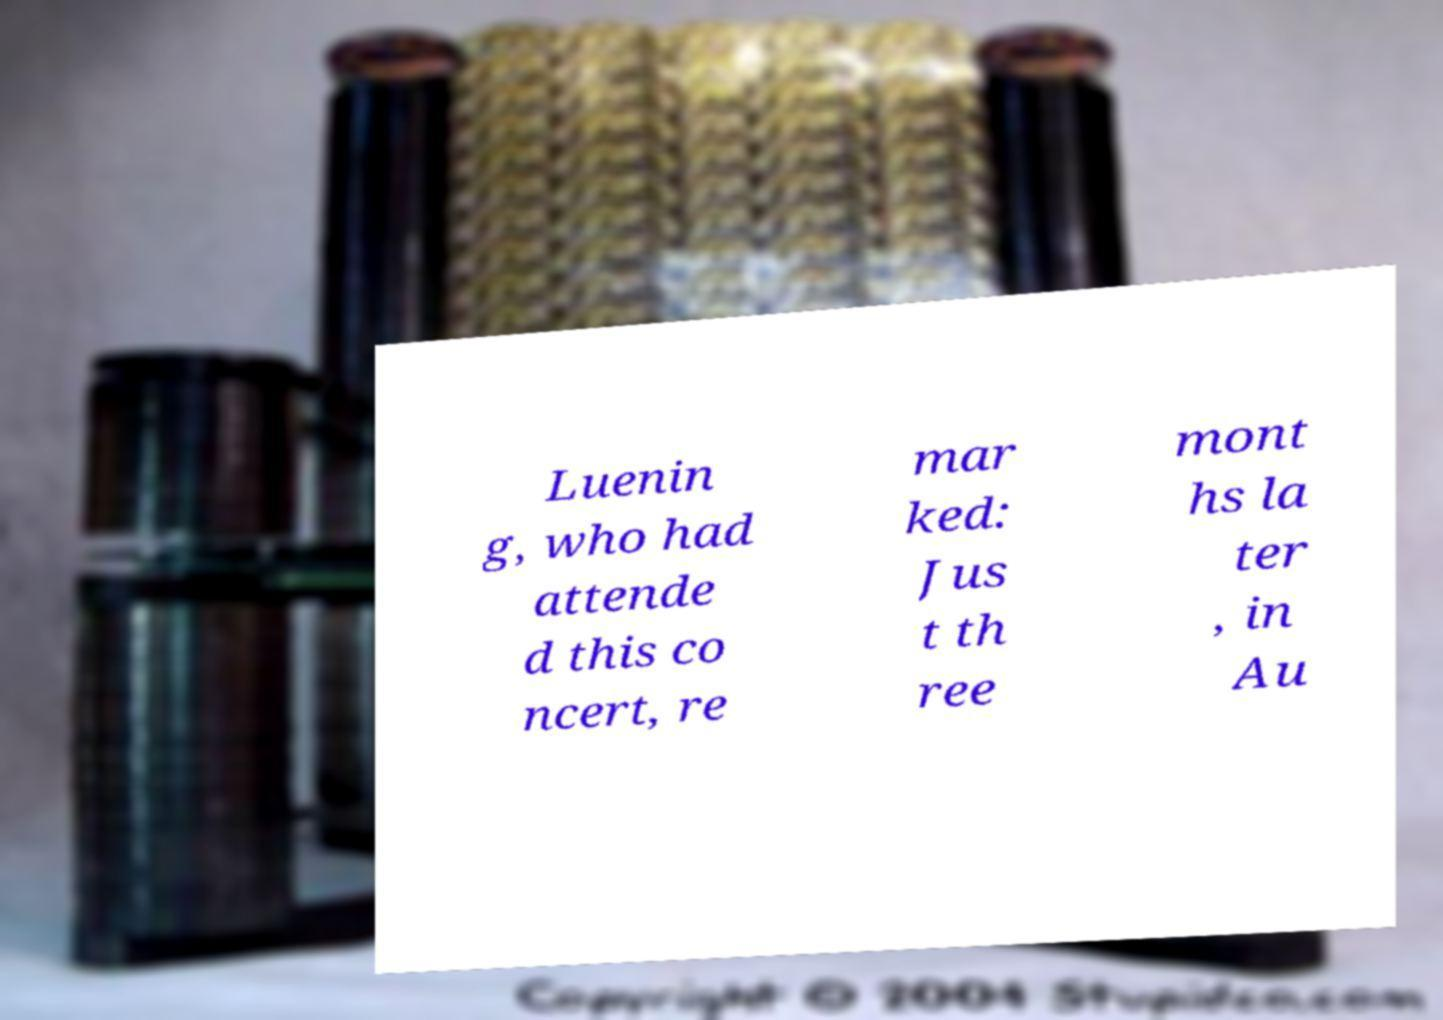For documentation purposes, I need the text within this image transcribed. Could you provide that? Luenin g, who had attende d this co ncert, re mar ked: Jus t th ree mont hs la ter , in Au 